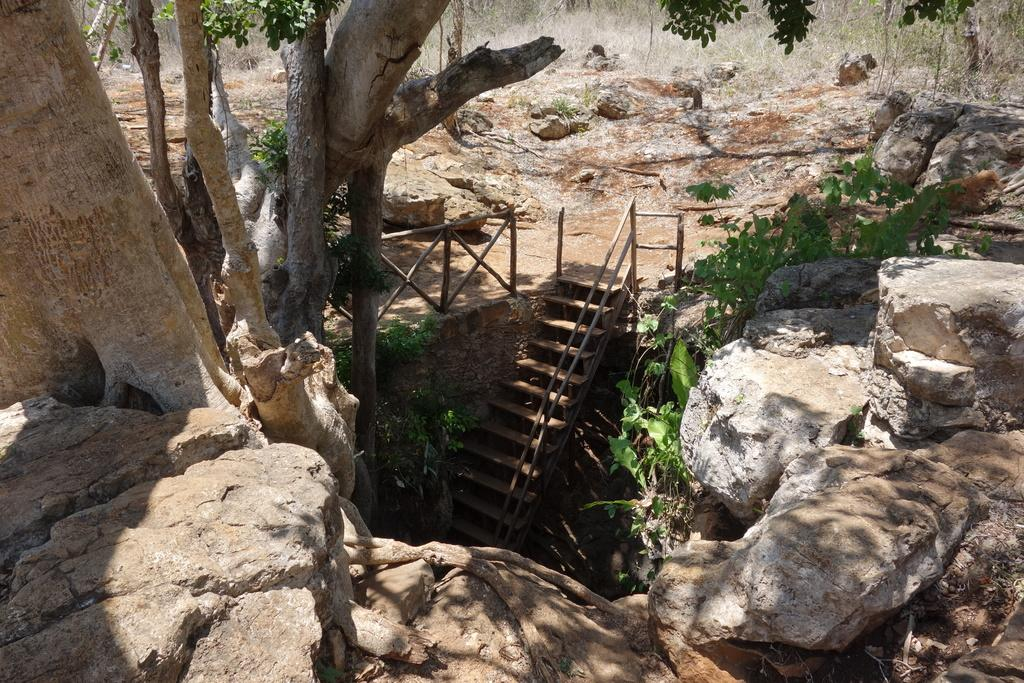What type of natural elements can be seen in the image? There are rocks, trees, and green leaves in the image. Are there any man-made structures visible in the image? Yes, there are stairs in the image. What is the color of the leaves in the image? The leaves in the image are green. What grade is the farmer teaching in the image? There is no farmer or any indication of a teaching scenario in the image. 